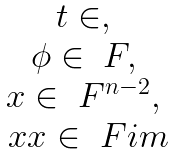<formula> <loc_0><loc_0><loc_500><loc_500>\begin{matrix} t \in \real , \\ \phi \in \ F , \\ x \in \ F ^ { n - 2 } , \\ \ x x \in \ F i m \end{matrix}</formula> 